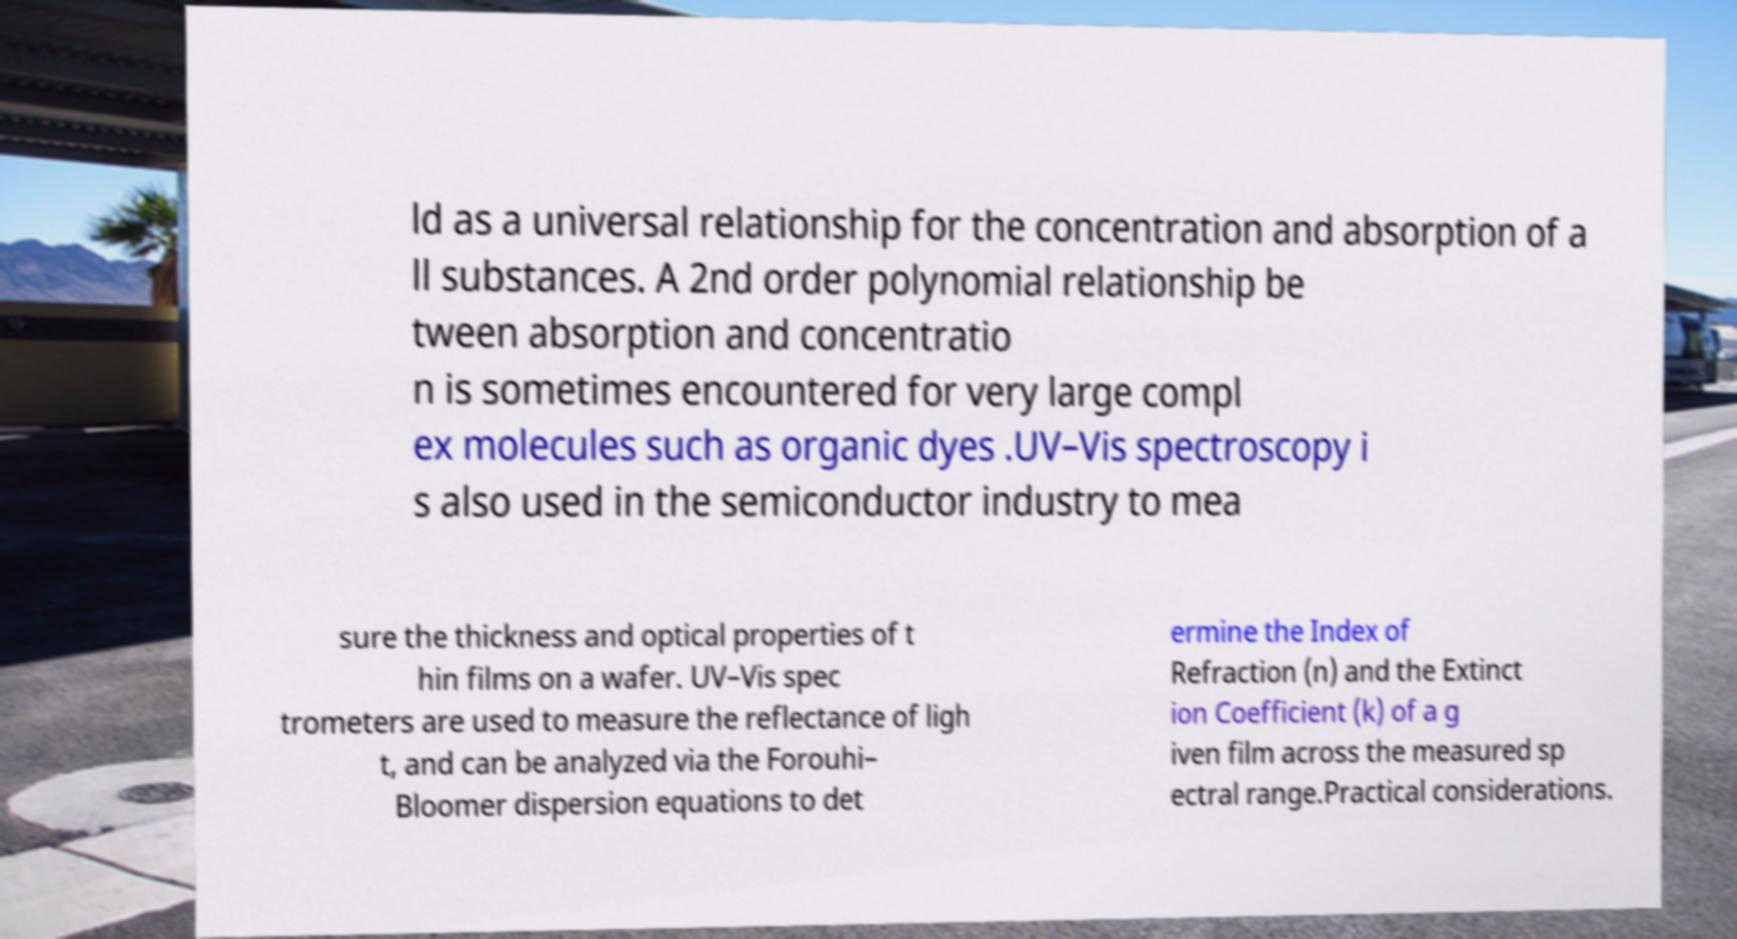For documentation purposes, I need the text within this image transcribed. Could you provide that? ld as a universal relationship for the concentration and absorption of a ll substances. A 2nd order polynomial relationship be tween absorption and concentratio n is sometimes encountered for very large compl ex molecules such as organic dyes .UV–Vis spectroscopy i s also used in the semiconductor industry to mea sure the thickness and optical properties of t hin films on a wafer. UV–Vis spec trometers are used to measure the reflectance of ligh t, and can be analyzed via the Forouhi– Bloomer dispersion equations to det ermine the Index of Refraction (n) and the Extinct ion Coefficient (k) of a g iven film across the measured sp ectral range.Practical considerations. 